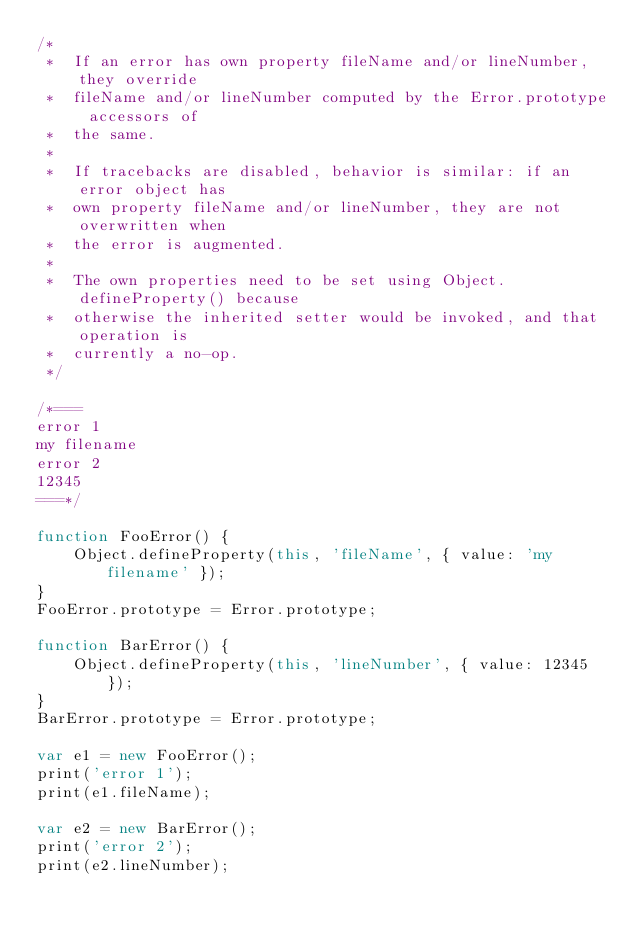<code> <loc_0><loc_0><loc_500><loc_500><_JavaScript_>/*
 *  If an error has own property fileName and/or lineNumber, they override
 *  fileName and/or lineNumber computed by the Error.prototype accessors of
 *  the same.
 *
 *  If tracebacks are disabled, behavior is similar: if an error object has
 *  own property fileName and/or lineNumber, they are not overwritten when
 *  the error is augmented.
 *
 *  The own properties need to be set using Object.defineProperty() because
 *  otherwise the inherited setter would be invoked, and that operation is
 *  currently a no-op.
 */

/*===
error 1
my filename
error 2
12345
===*/

function FooError() {
    Object.defineProperty(this, 'fileName', { value: 'my filename' });
}
FooError.prototype = Error.prototype;

function BarError() {
    Object.defineProperty(this, 'lineNumber', { value: 12345 });
}
BarError.prototype = Error.prototype;

var e1 = new FooError();
print('error 1');
print(e1.fileName);

var e2 = new BarError();
print('error 2');
print(e2.lineNumber);
</code> 